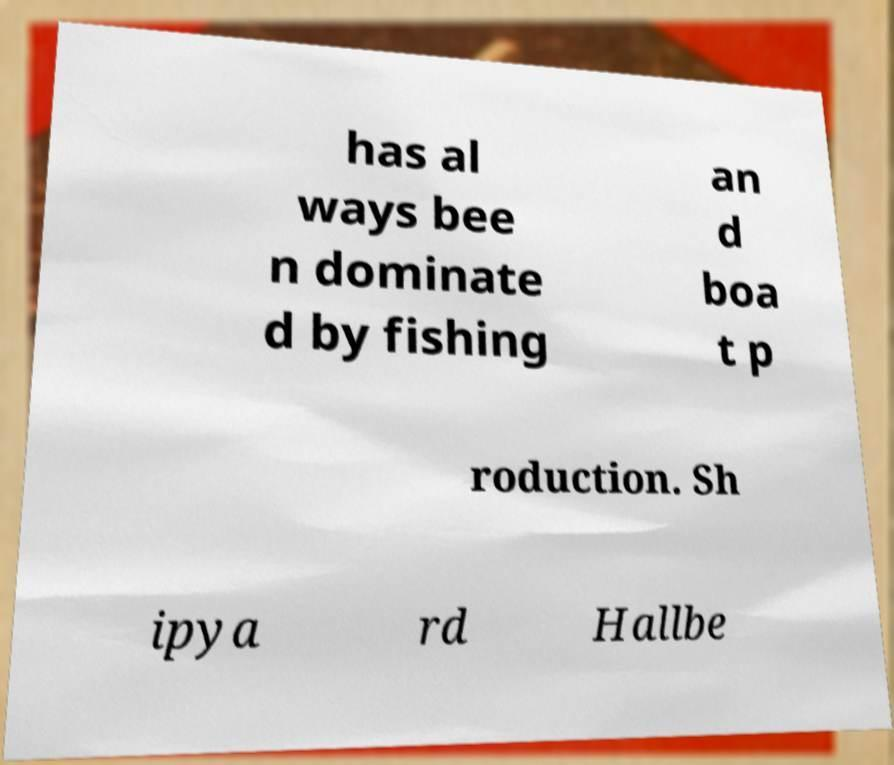I need the written content from this picture converted into text. Can you do that? has al ways bee n dominate d by fishing an d boa t p roduction. Sh ipya rd Hallbe 